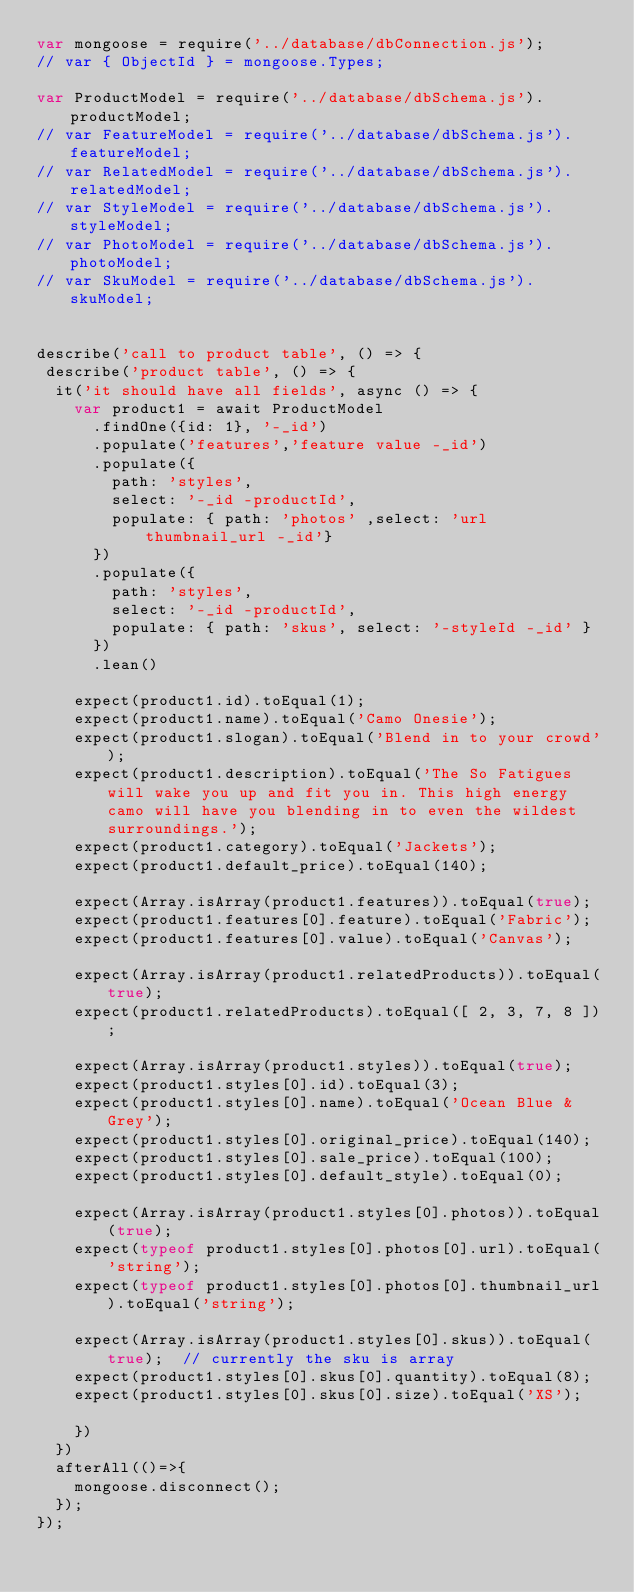<code> <loc_0><loc_0><loc_500><loc_500><_JavaScript_>var mongoose = require('../database/dbConnection.js');
// var { ObjectId } = mongoose.Types;

var ProductModel = require('../database/dbSchema.js').productModel;
// var FeatureModel = require('../database/dbSchema.js').featureModel;
// var RelatedModel = require('../database/dbSchema.js').relatedModel;
// var StyleModel = require('../database/dbSchema.js').styleModel;
// var PhotoModel = require('../database/dbSchema.js').photoModel;
// var SkuModel = require('../database/dbSchema.js').skuModel;


describe('call to product table', () => {
 describe('product table', () => {
  it('it should have all fields', async () => {
    var product1 = await ProductModel
      .findOne({id: 1}, '-_id')
      .populate('features','feature value -_id')
      .populate({
        path: 'styles',
        select: '-_id -productId',
        populate: { path: 'photos' ,select: 'url thumbnail_url -_id'}
      })
      .populate({
        path: 'styles',
        select: '-_id -productId',
        populate: { path: 'skus', select: '-styleId -_id' }
      })
      .lean()

    expect(product1.id).toEqual(1);
    expect(product1.name).toEqual('Camo Onesie');
    expect(product1.slogan).toEqual('Blend in to your crowd');
    expect(product1.description).toEqual('The So Fatigues will wake you up and fit you in. This high energy camo will have you blending in to even the wildest surroundings.');
    expect(product1.category).toEqual('Jackets');
    expect(product1.default_price).toEqual(140);

    expect(Array.isArray(product1.features)).toEqual(true);
    expect(product1.features[0].feature).toEqual('Fabric');
    expect(product1.features[0].value).toEqual('Canvas');

    expect(Array.isArray(product1.relatedProducts)).toEqual(true);
    expect(product1.relatedProducts).toEqual([ 2, 3, 7, 8 ]);

    expect(Array.isArray(product1.styles)).toEqual(true);
    expect(product1.styles[0].id).toEqual(3);
    expect(product1.styles[0].name).toEqual('Ocean Blue & Grey');
    expect(product1.styles[0].original_price).toEqual(140);
    expect(product1.styles[0].sale_price).toEqual(100);
    expect(product1.styles[0].default_style).toEqual(0);

    expect(Array.isArray(product1.styles[0].photos)).toEqual(true);
    expect(typeof product1.styles[0].photos[0].url).toEqual('string');
    expect(typeof product1.styles[0].photos[0].thumbnail_url).toEqual('string');

    expect(Array.isArray(product1.styles[0].skus)).toEqual(true);  // currently the sku is array
    expect(product1.styles[0].skus[0].quantity).toEqual(8);
    expect(product1.styles[0].skus[0].size).toEqual('XS');

    })
  })
  afterAll(()=>{
    mongoose.disconnect();
  });
});</code> 